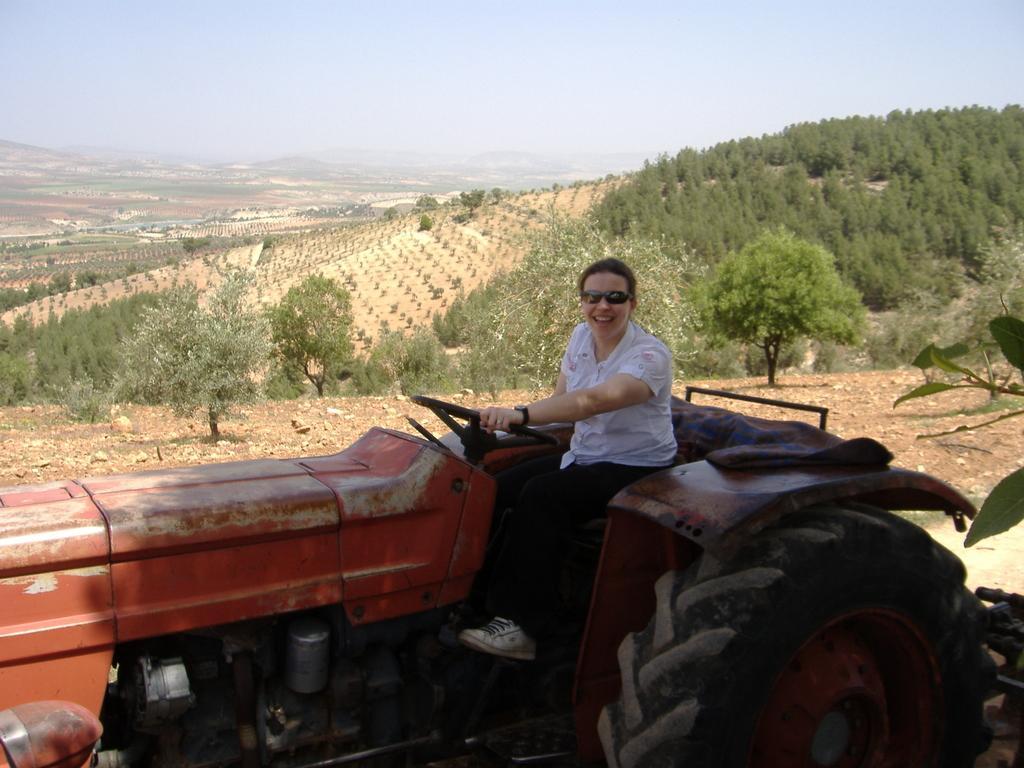How would you summarize this image in a sentence or two? On the right side, there is a woman in white color shirt, holding steering of a tractor. Beside this tractor, there is a tree. In the background, there are trees and plants on the hill, there are trees and plants on the ground, there are mountains and there are clouds in the blue sky. 